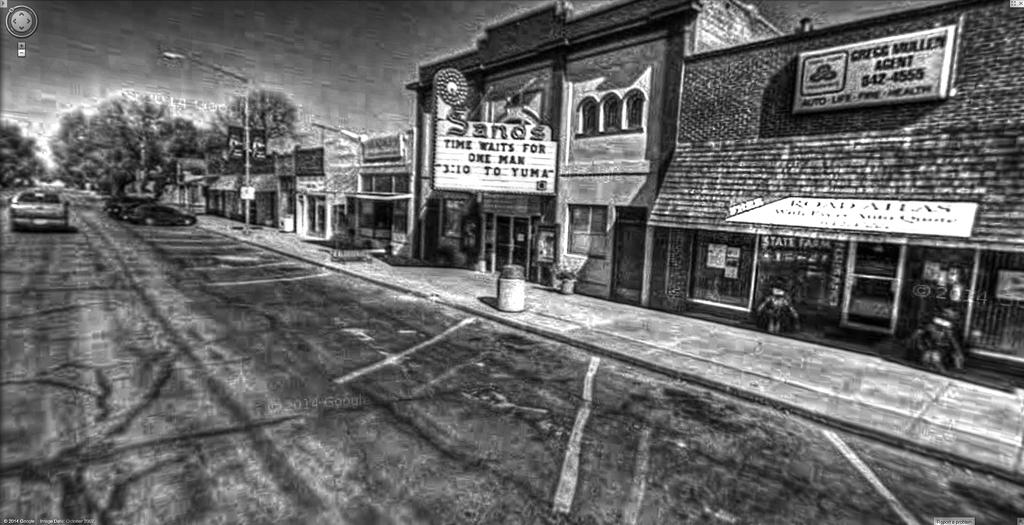<image>
Describe the image concisely. A small town with a movie theater called the Sands playing a movie that states time waits for no one. 